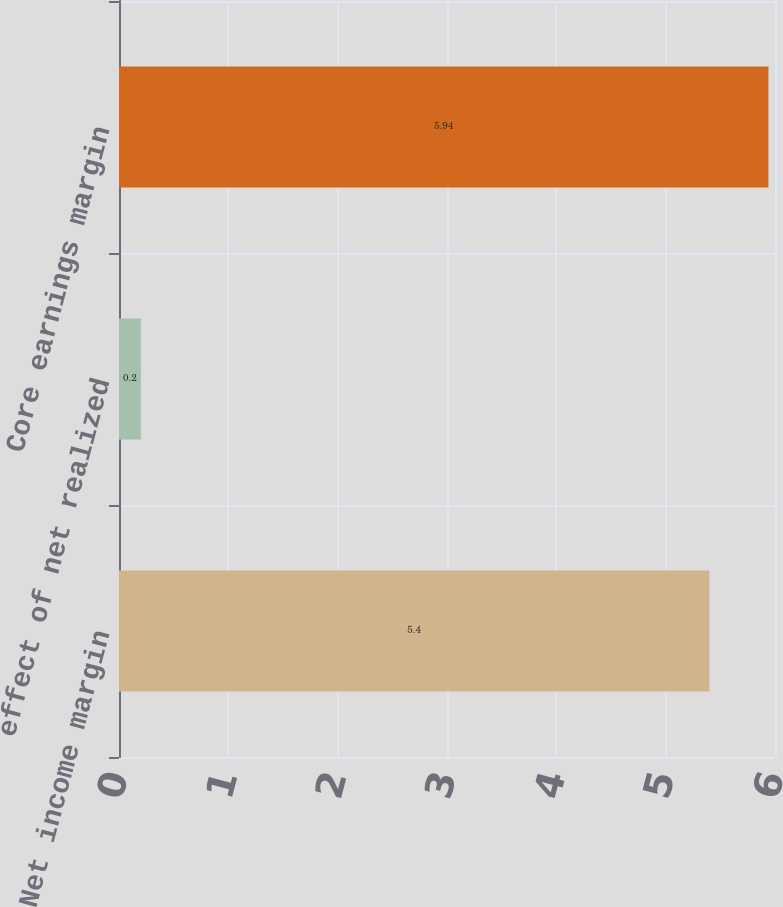Convert chart. <chart><loc_0><loc_0><loc_500><loc_500><bar_chart><fcel>Net income margin<fcel>effect of net realized<fcel>Core earnings margin<nl><fcel>5.4<fcel>0.2<fcel>5.94<nl></chart> 